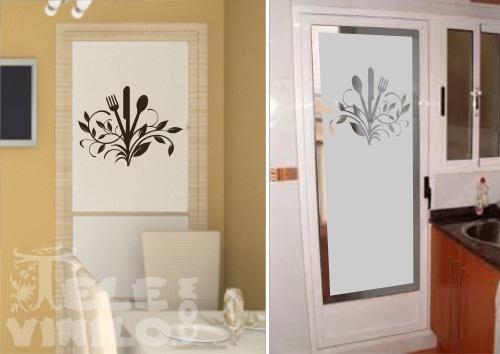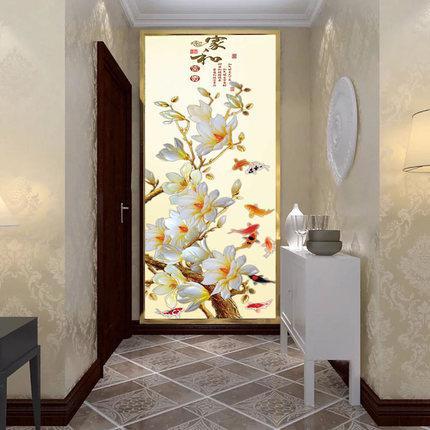The first image is the image on the left, the second image is the image on the right. Evaluate the accuracy of this statement regarding the images: "The wall in the right image is decorated with art of only flowers.". Is it true? Answer yes or no. Yes. The first image is the image on the left, the second image is the image on the right. For the images displayed, is the sentence "There are three sheet of glass that are decorated with art and at least one different image." factually correct? Answer yes or no. Yes. 